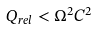<formula> <loc_0><loc_0><loc_500><loc_500>Q _ { r e l } < \Omega ^ { 2 } C ^ { 2 }</formula> 